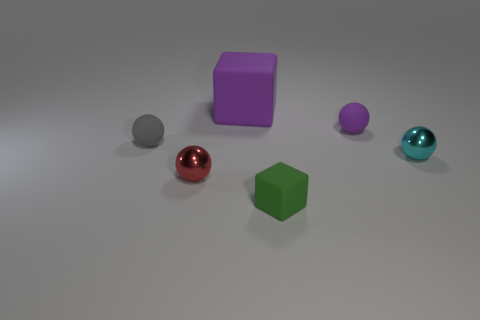Add 4 large purple cylinders. How many objects exist? 10 Subtract all small cyan shiny balls. How many balls are left? 3 Subtract all spheres. How many objects are left? 2 Subtract all cyan balls. How many balls are left? 3 Subtract all gray balls. Subtract all gray cubes. How many balls are left? 3 Subtract all purple cylinders. How many red spheres are left? 1 Subtract all small purple matte things. Subtract all tiny yellow shiny balls. How many objects are left? 5 Add 4 big purple things. How many big purple things are left? 5 Add 3 spheres. How many spheres exist? 7 Subtract 0 green balls. How many objects are left? 6 